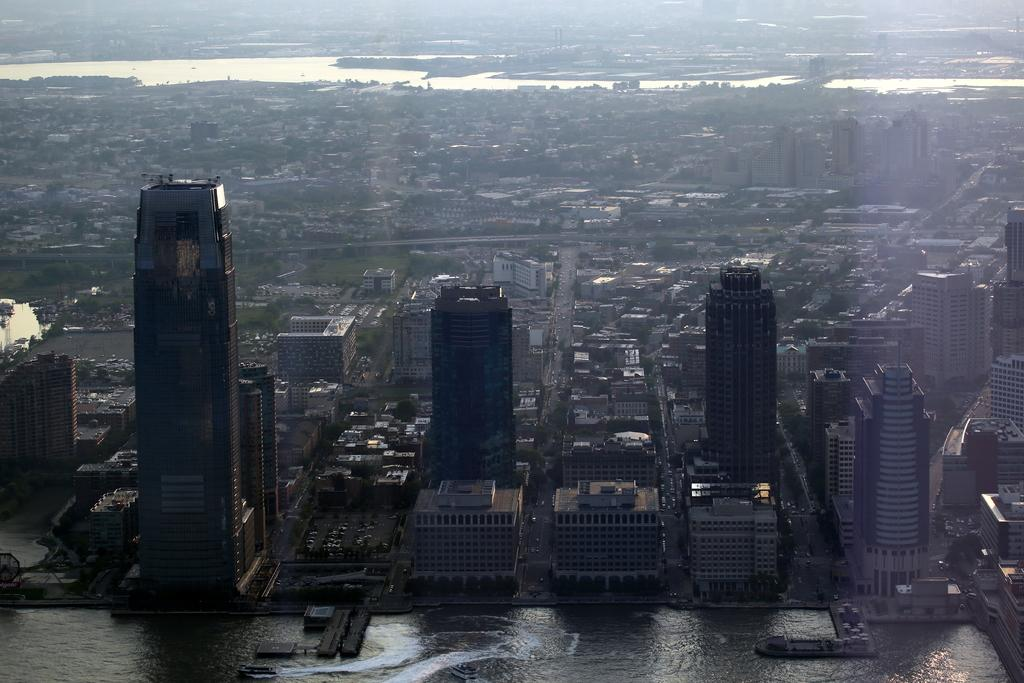What is the main subject of the image? The main subject of the image is many buildings. Can you describe the water visible in the image? There is water visible at the bottom and top of the image. What is the condition of the basketball in the image? There is no basketball present in the image. How can a beginner improve their skills in the image? There is no activity or skill-building depicted in the image, so it's not possible to answer that question. 